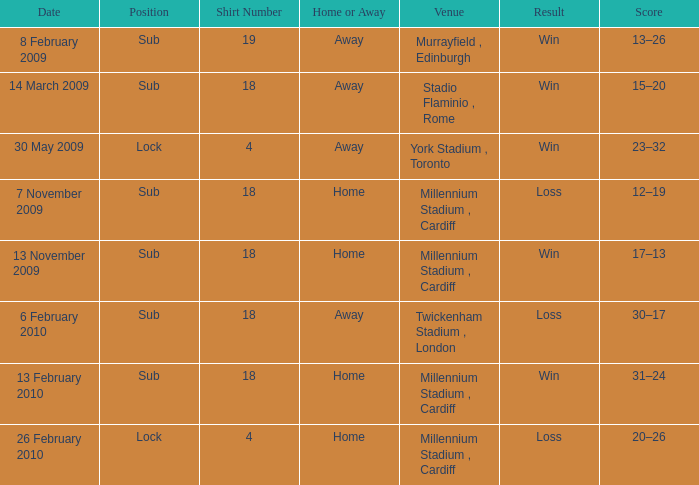Can you tell me the Score that has the Result of win, and the Date of 13 november 2009? 17–13. 